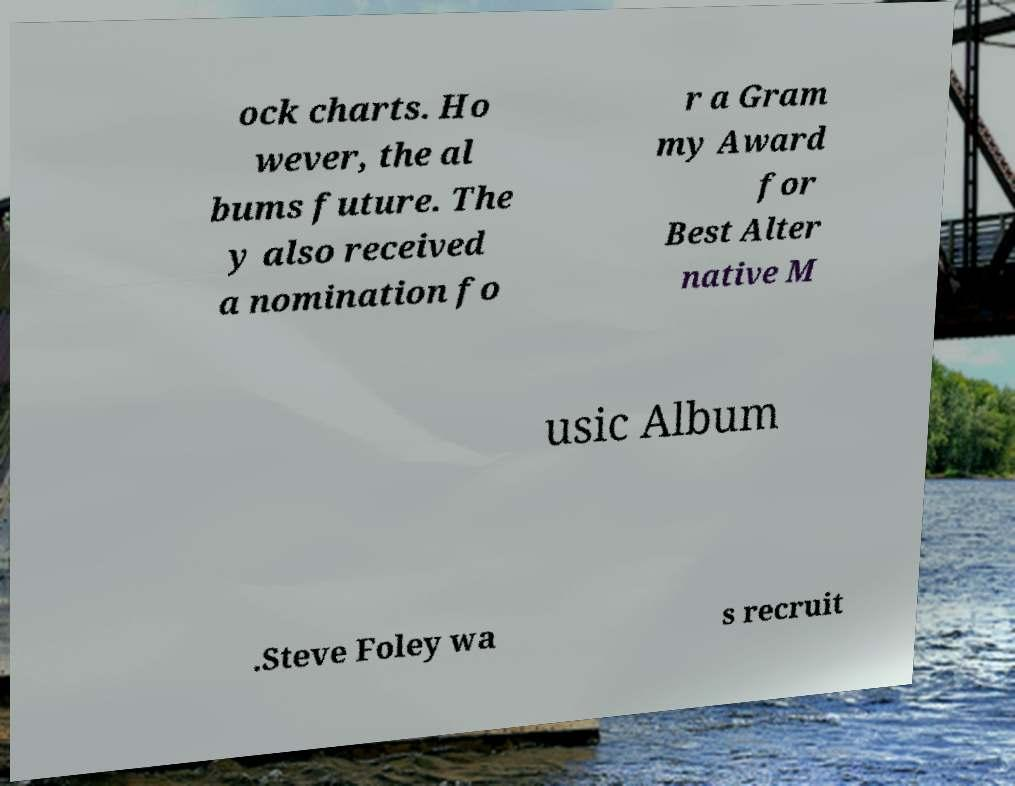There's text embedded in this image that I need extracted. Can you transcribe it verbatim? ock charts. Ho wever, the al bums future. The y also received a nomination fo r a Gram my Award for Best Alter native M usic Album .Steve Foley wa s recruit 